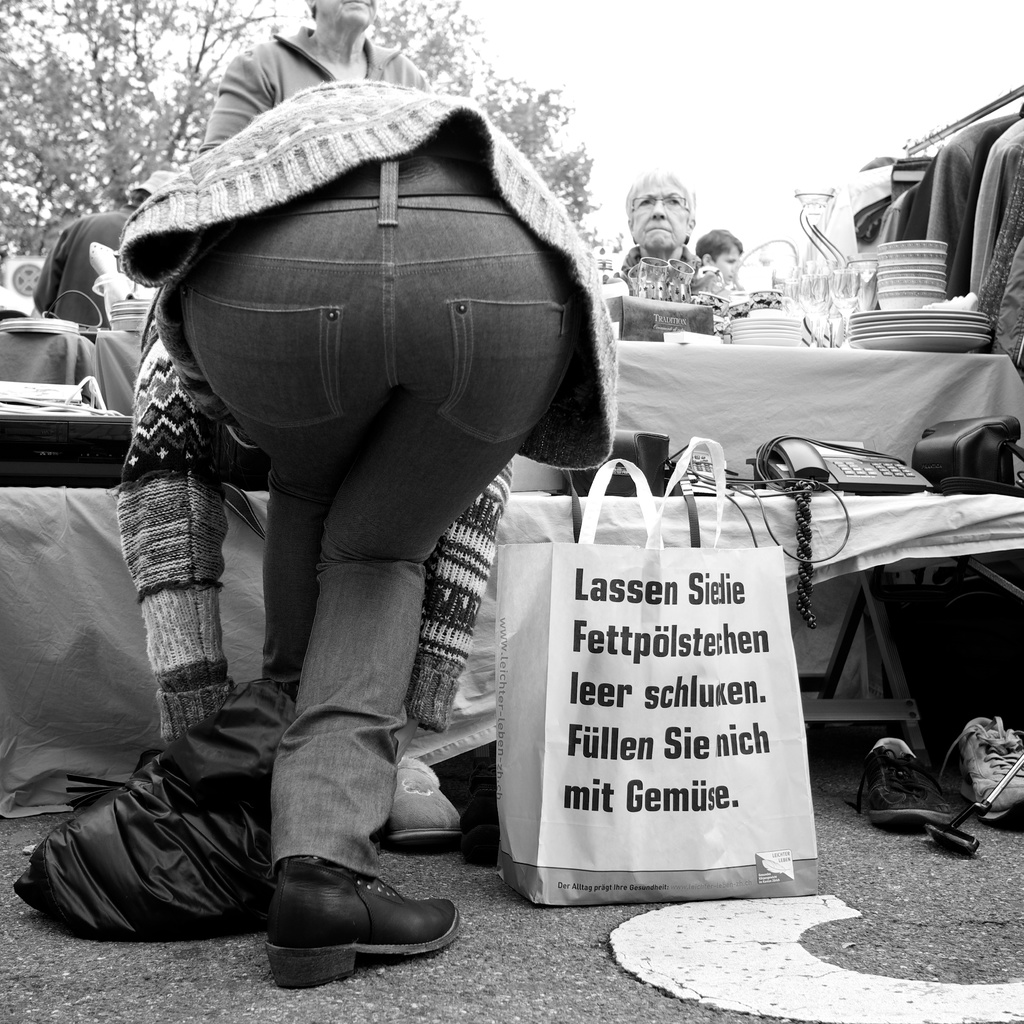Can you describe the types of items that might be for sale at this stall? The stall in question appears to sell a variety of items that could range from small antiques and collectibles to practical household goods. The presence of glassware and possibly some electronic items suggest a mix that could cater to both collectors looking for unique finds and everyday shoppers seeking utilitarian items. 